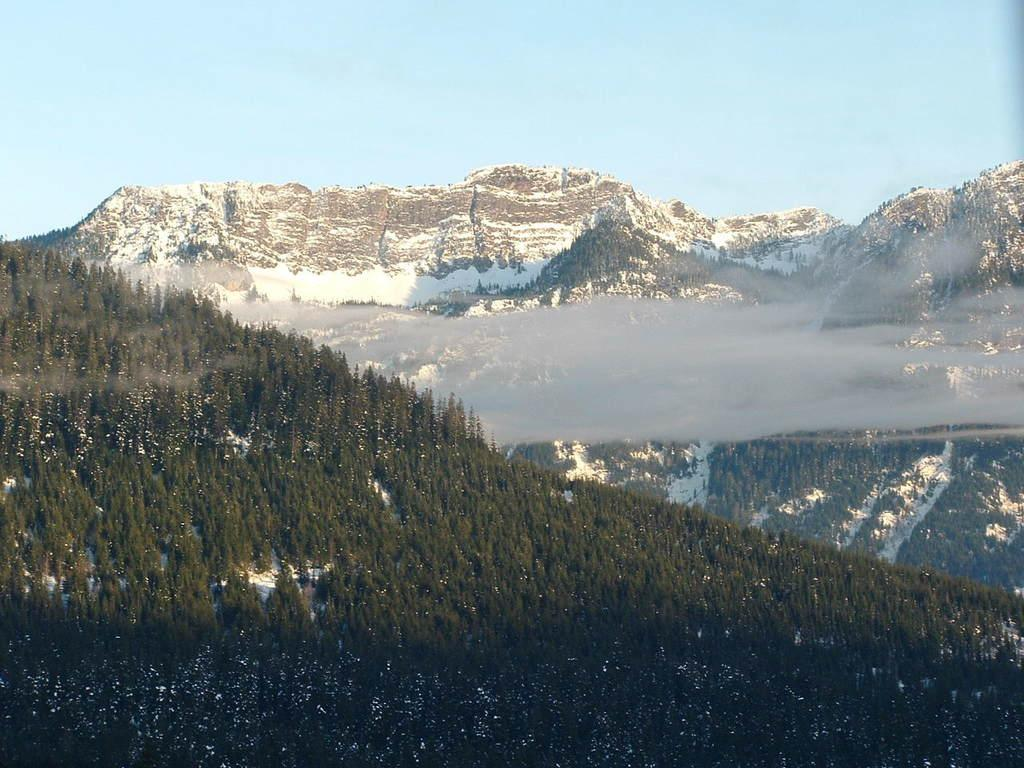What type of vegetation is present in the image? There are trees in the image. What is covering the ground in the image? The ground is covered with snow. What can be seen in the background of the image? There are mountains in the background of the image. How are the mountains affected by the weather in the image? The mountains are covered with snow, indicating that it is likely cold and snowy. What color is the hall in the image? There is no hall present in the image; it features trees, snow-covered ground, and snow-covered mountains. What type of spark can be seen coming from the trees in the image? There is no spark present in the image; it features trees, snow-covered ground, and snow-covered mountains. 